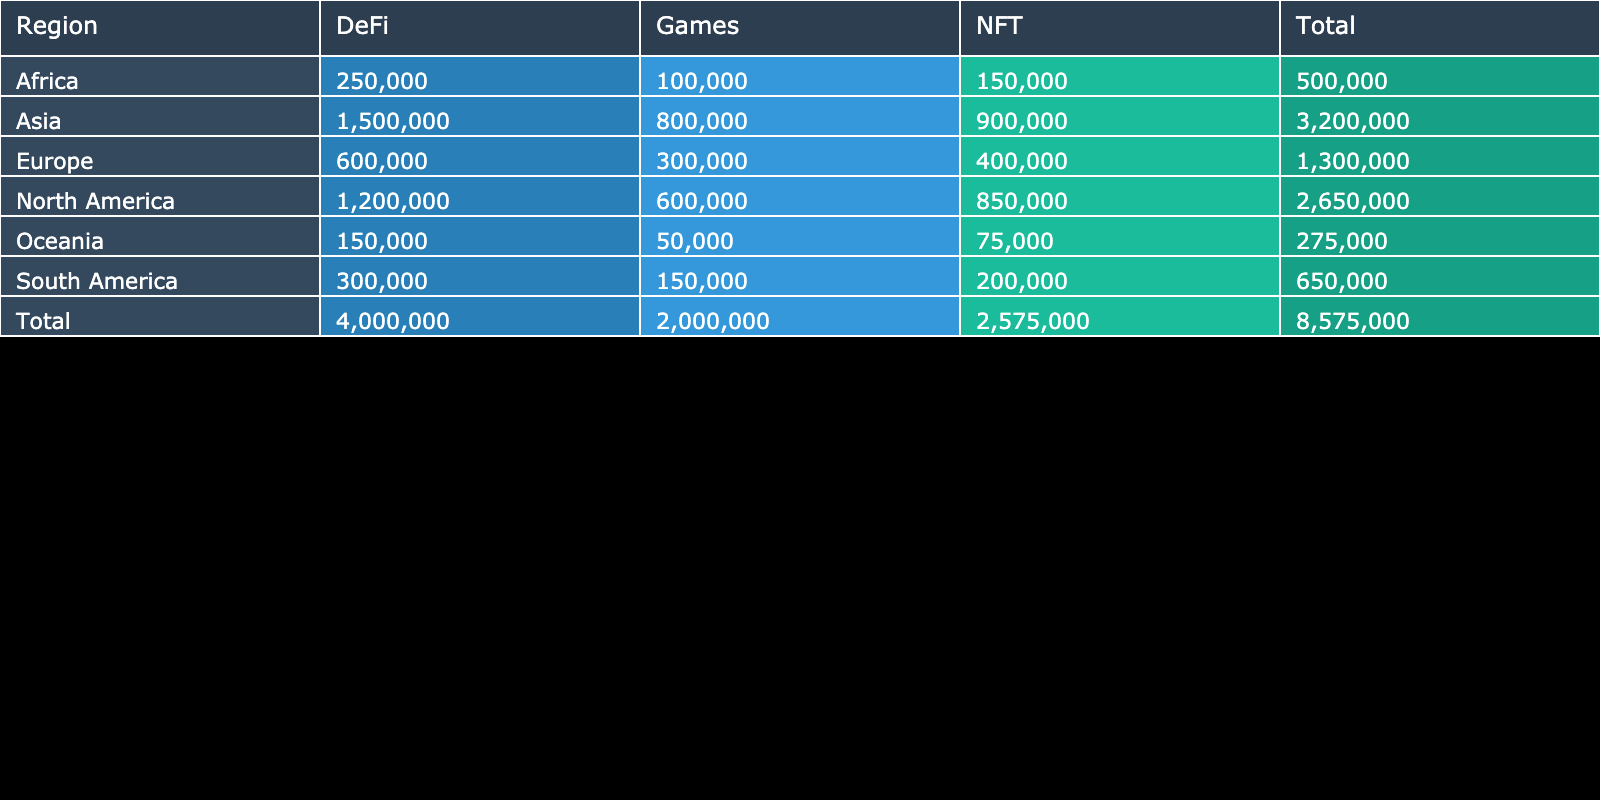What is the user activity level for Games in Asia? The user activity level for Games in Asia is directly listed in the table under the Asia row and Games column. It shows 800,000 users.
Answer: 800,000 Which region has the highest user activity level for DeFi? By comparing the values in the DeFi column across the regions, Asia shows the highest user activity level with 1,500,000 users.
Answer: Asia What is the total user activity level for North America across all categories? To find the total, sum the user activity levels for North America: 1,200,000 (DeFi) + 850,000 (NFT) + 600,000 (Games) = 2,650,000.
Answer: 2,650,000 Is the user activity level for Africa's NFT category greater than the user activity level for Oceania's NFT category? Africa's NFT user activity level is 150,000, while Oceania's is 75,000. Since 150,000 is greater than 75,000, the answer is yes.
Answer: Yes What is the difference in user activity levels between DeFi and Games in Europe? In Europe, the user activity level for DeFi is 600,000, and for Games, it is 300,000. The difference is 600,000 - 300,000 = 300,000.
Answer: 300,000 Which region has the least total user activity level, and what is this total? Calculate the totals for each region: North America (2,650,000), Europe (1,300,000), Asia (2,400,000), South America (650,000), Africa (500,000), Oceania (275,000). Oceania has the least total with 275,000.
Answer: Oceania, 275,000 What percentage of user activity in Asia is attributed to DeFi? Asia's total user activity level is 3,200,000 (1,500,000 DeFi + 900,000 NFT + 800,000 Games). DeFi's user level is 1,500,000. The percentage is (1,500,000 / 3,200,000) * 100 = 46.875%.
Answer: 46.88% In which category does South America have the highest user activity level? For South America, the user activity levels are: DeFi (300,000), NFT (200,000), Games (150,000). The highest level is in DeFi with 300,000 users.
Answer: DeFi Are there more users engaged in Games in North America compared to Africa? North America has 600,000 users in Games, while Africa has 100,000. Since 600,000 is greater than 100,000, the answer is yes.
Answer: Yes 